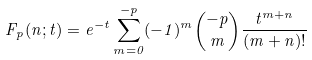Convert formula to latex. <formula><loc_0><loc_0><loc_500><loc_500>F _ { p } ( n ; t ) = e ^ { - t } \sum _ { m = 0 } ^ { - p } ( - 1 ) ^ { m } \binom { - p } { m } \frac { t ^ { m + n } } { ( m + n ) ! }</formula> 